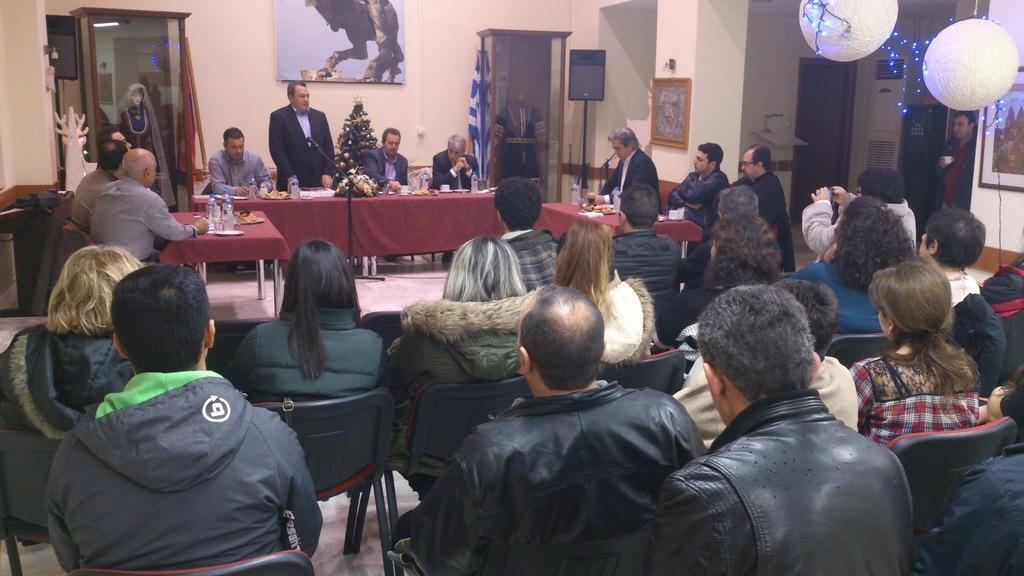In one or two sentences, can you explain what this image depicts? This picture shows a meeting room were all the people seated on the chair and a person standing and speaking to the audience 